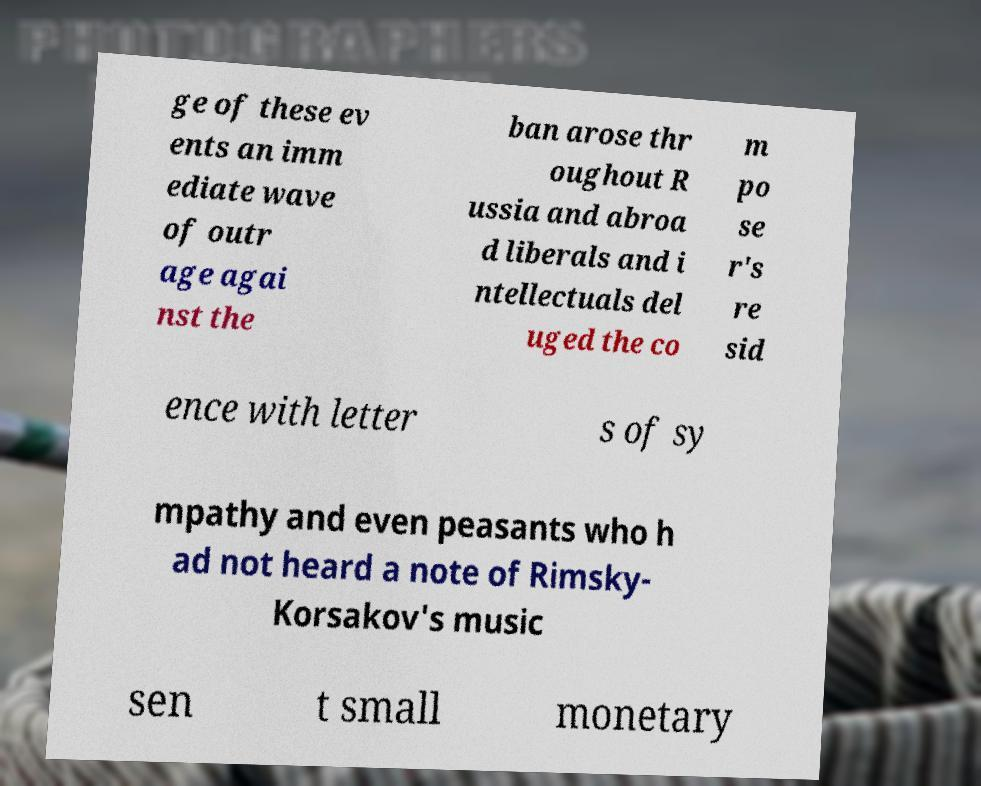Could you extract and type out the text from this image? ge of these ev ents an imm ediate wave of outr age agai nst the ban arose thr oughout R ussia and abroa d liberals and i ntellectuals del uged the co m po se r's re sid ence with letter s of sy mpathy and even peasants who h ad not heard a note of Rimsky- Korsakov's music sen t small monetary 